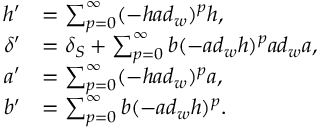Convert formula to latex. <formula><loc_0><loc_0><loc_500><loc_500>\begin{array} { r l } { h ^ { \prime } } & { = \sum _ { p = 0 } ^ { \infty } ( - h a d _ { w } ) ^ { p } h , } \\ { \delta ^ { \prime } } & { = \delta _ { S } + \sum _ { p = 0 } ^ { \infty } b ( - a d _ { w } h ) ^ { p } a d _ { w } a , } \\ { a ^ { \prime } } & { = \sum _ { p = 0 } ^ { \infty } ( - h a d _ { w } ) ^ { p } a , } \\ { b ^ { \prime } } & { = \sum _ { p = 0 } ^ { \infty } b ( - a d _ { w } h ) ^ { p } . } \end{array}</formula> 